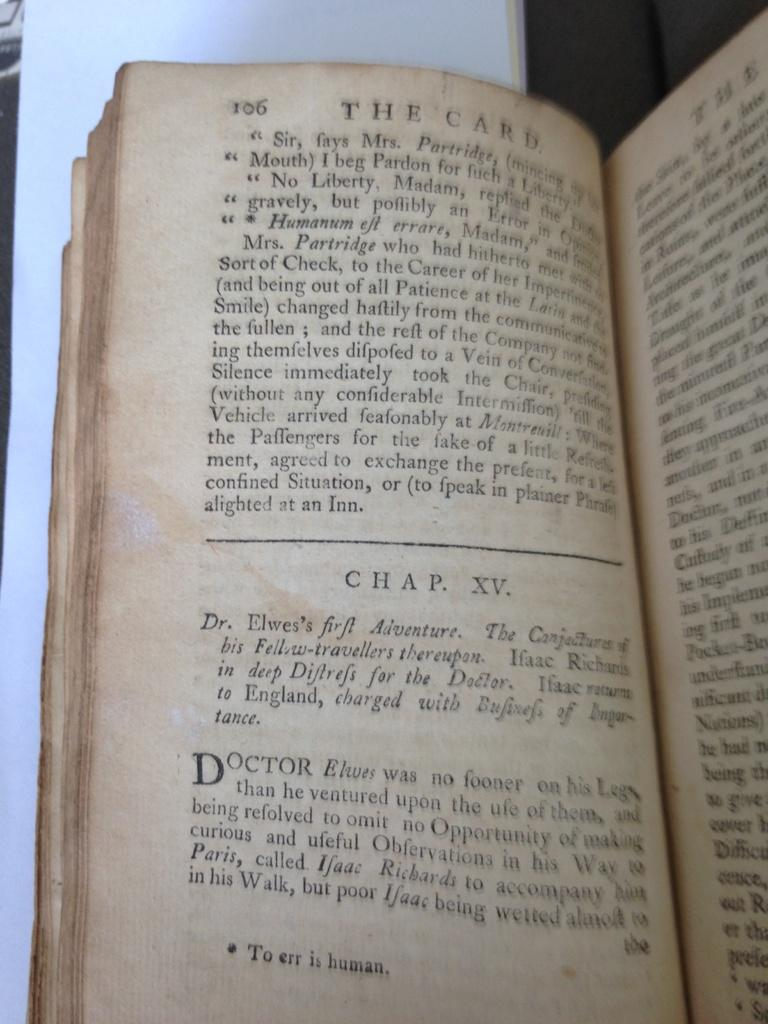<image>
Summarize the visual content of the image. An old book entitled The Card is open to chapter fifteen. 